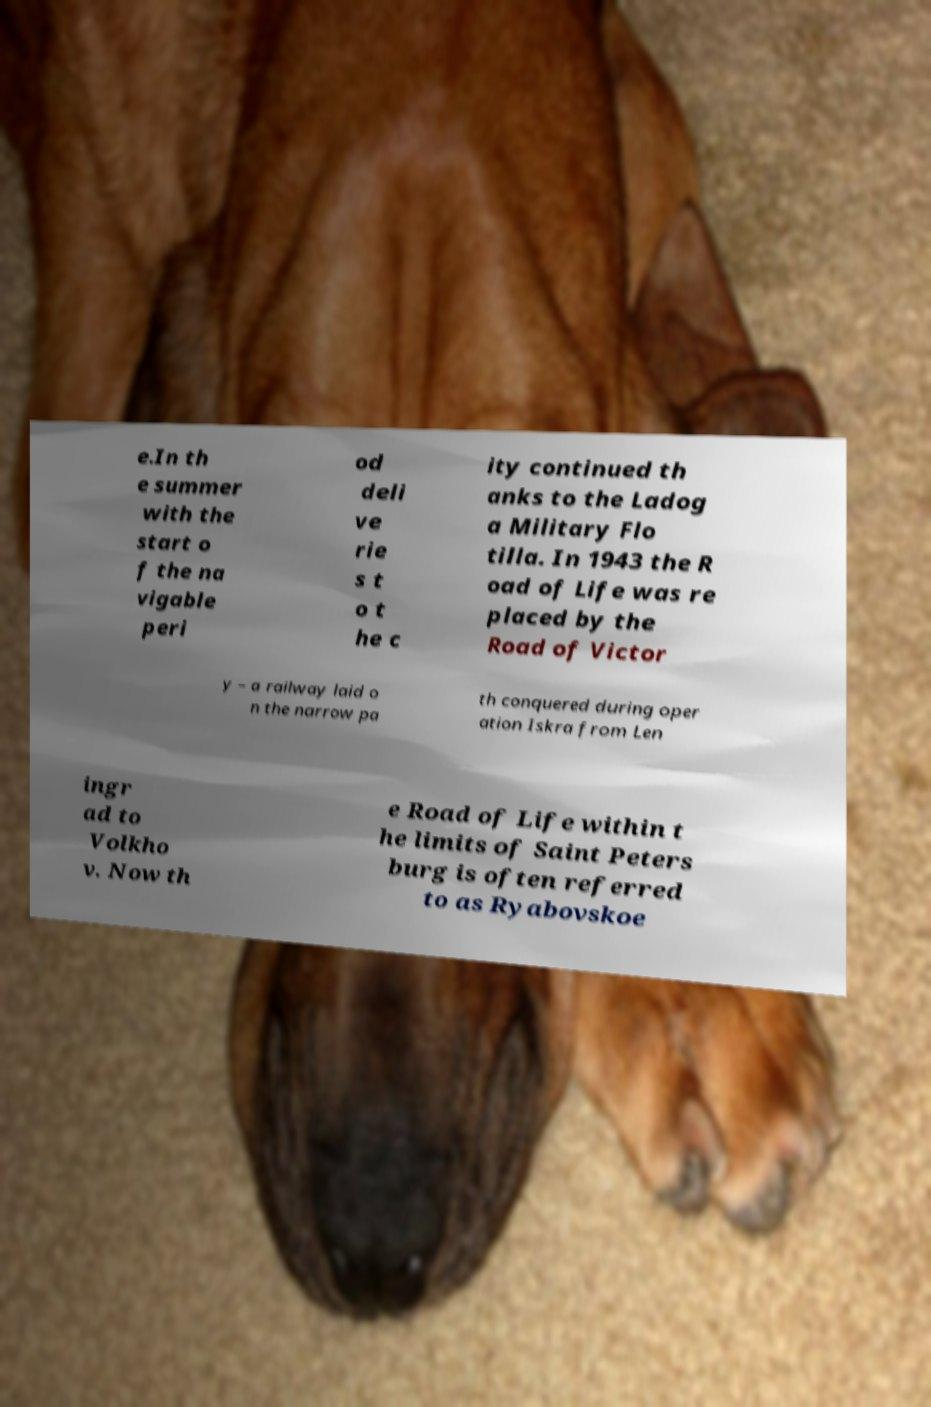Could you extract and type out the text from this image? e.In th e summer with the start o f the na vigable peri od deli ve rie s t o t he c ity continued th anks to the Ladog a Military Flo tilla. In 1943 the R oad of Life was re placed by the Road of Victor y – a railway laid o n the narrow pa th conquered during oper ation Iskra from Len ingr ad to Volkho v. Now th e Road of Life within t he limits of Saint Peters burg is often referred to as Ryabovskoe 